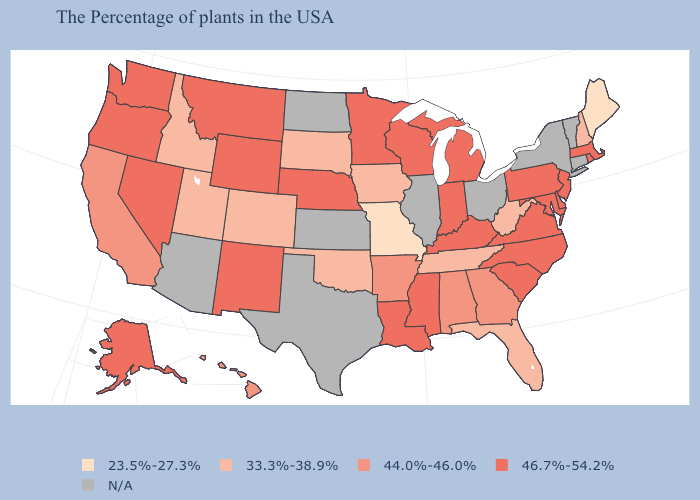Name the states that have a value in the range N/A?
Concise answer only. Vermont, Connecticut, New York, Ohio, Illinois, Kansas, Texas, North Dakota, Arizona. What is the value of Louisiana?
Give a very brief answer. 46.7%-54.2%. What is the value of New Mexico?
Concise answer only. 46.7%-54.2%. Which states have the lowest value in the Northeast?
Be succinct. Maine. Does Colorado have the lowest value in the West?
Write a very short answer. Yes. Among the states that border Michigan , which have the highest value?
Answer briefly. Indiana, Wisconsin. Does Maine have the lowest value in the USA?
Concise answer only. Yes. What is the value of Kentucky?
Keep it brief. 46.7%-54.2%. What is the value of Michigan?
Concise answer only. 46.7%-54.2%. Name the states that have a value in the range 46.7%-54.2%?
Keep it brief. Massachusetts, Rhode Island, New Jersey, Delaware, Maryland, Pennsylvania, Virginia, North Carolina, South Carolina, Michigan, Kentucky, Indiana, Wisconsin, Mississippi, Louisiana, Minnesota, Nebraska, Wyoming, New Mexico, Montana, Nevada, Washington, Oregon, Alaska. How many symbols are there in the legend?
Short answer required. 5. 